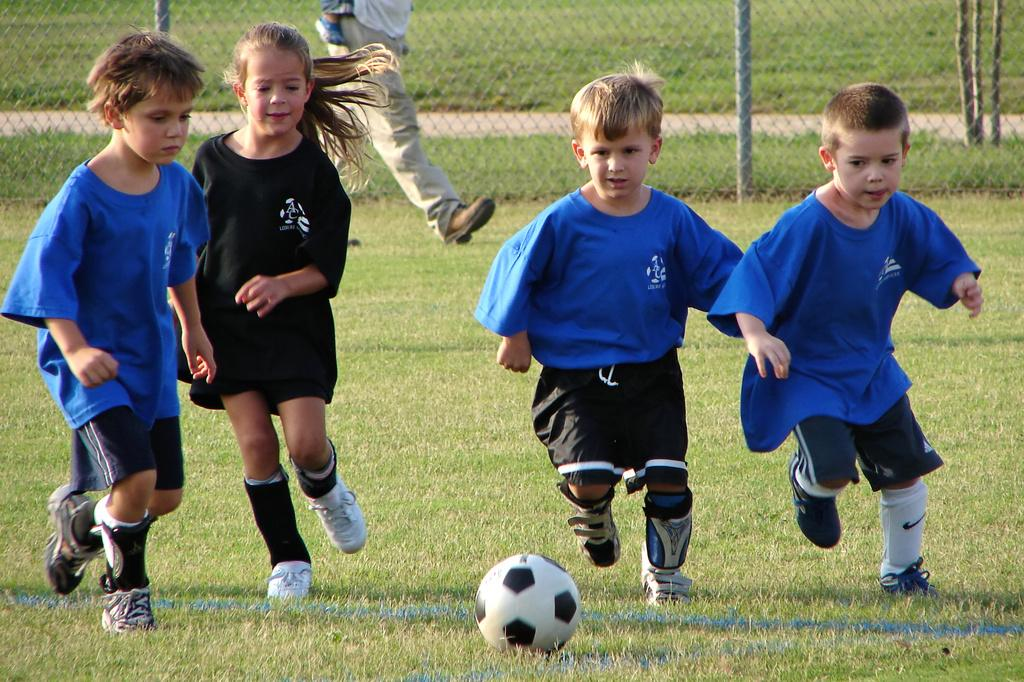How many people are present in the image? There are four people on the ground in the image. What object is in front of the people? There is a ball in front of front of the people. Can you describe the background of the image? In the background of the image, there is a person, a fence, grass, and wooden sticks. What type of train can be seen in the image? There is no train present in the image. What tools might the carpenter be using in the image? There is no carpenter or tools present in the image. 